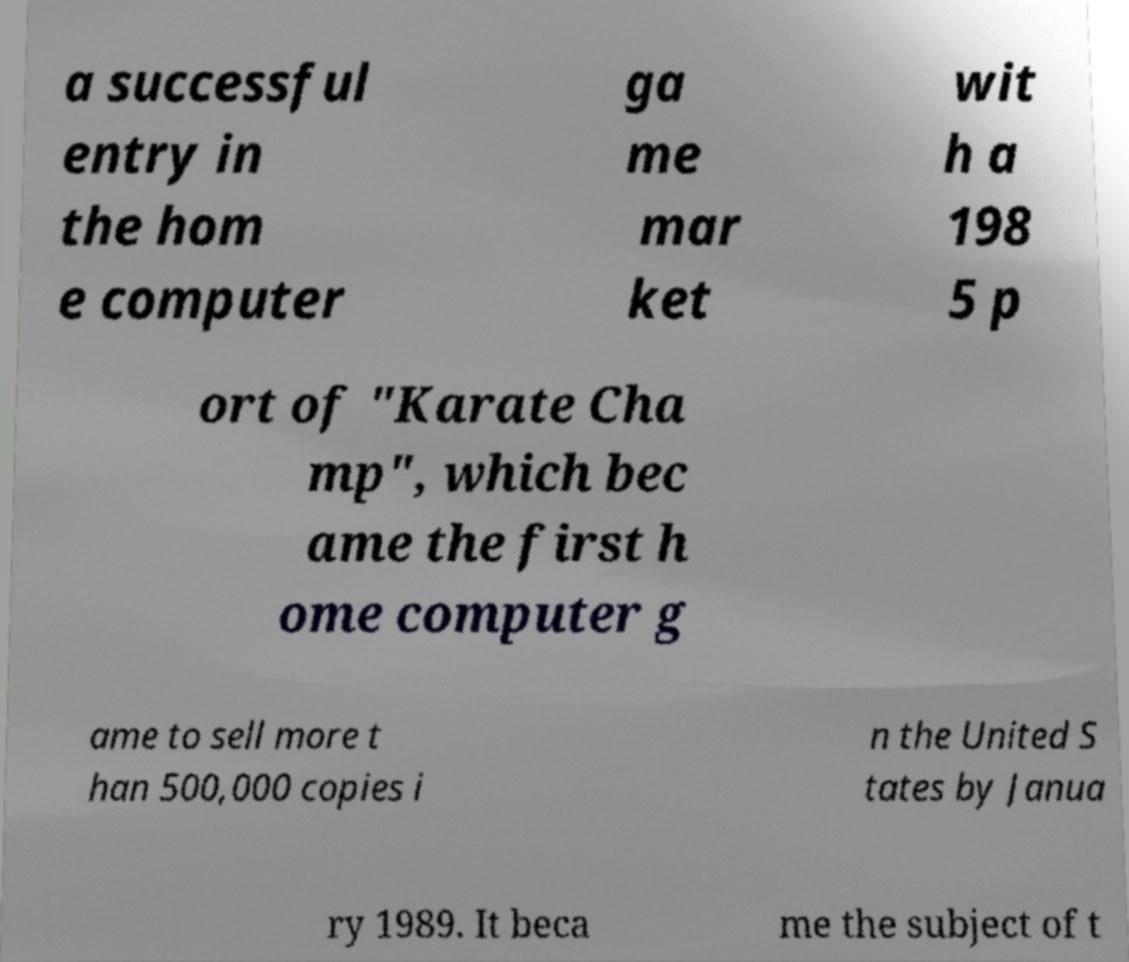There's text embedded in this image that I need extracted. Can you transcribe it verbatim? a successful entry in the hom e computer ga me mar ket wit h a 198 5 p ort of "Karate Cha mp", which bec ame the first h ome computer g ame to sell more t han 500,000 copies i n the United S tates by Janua ry 1989. It beca me the subject of t 